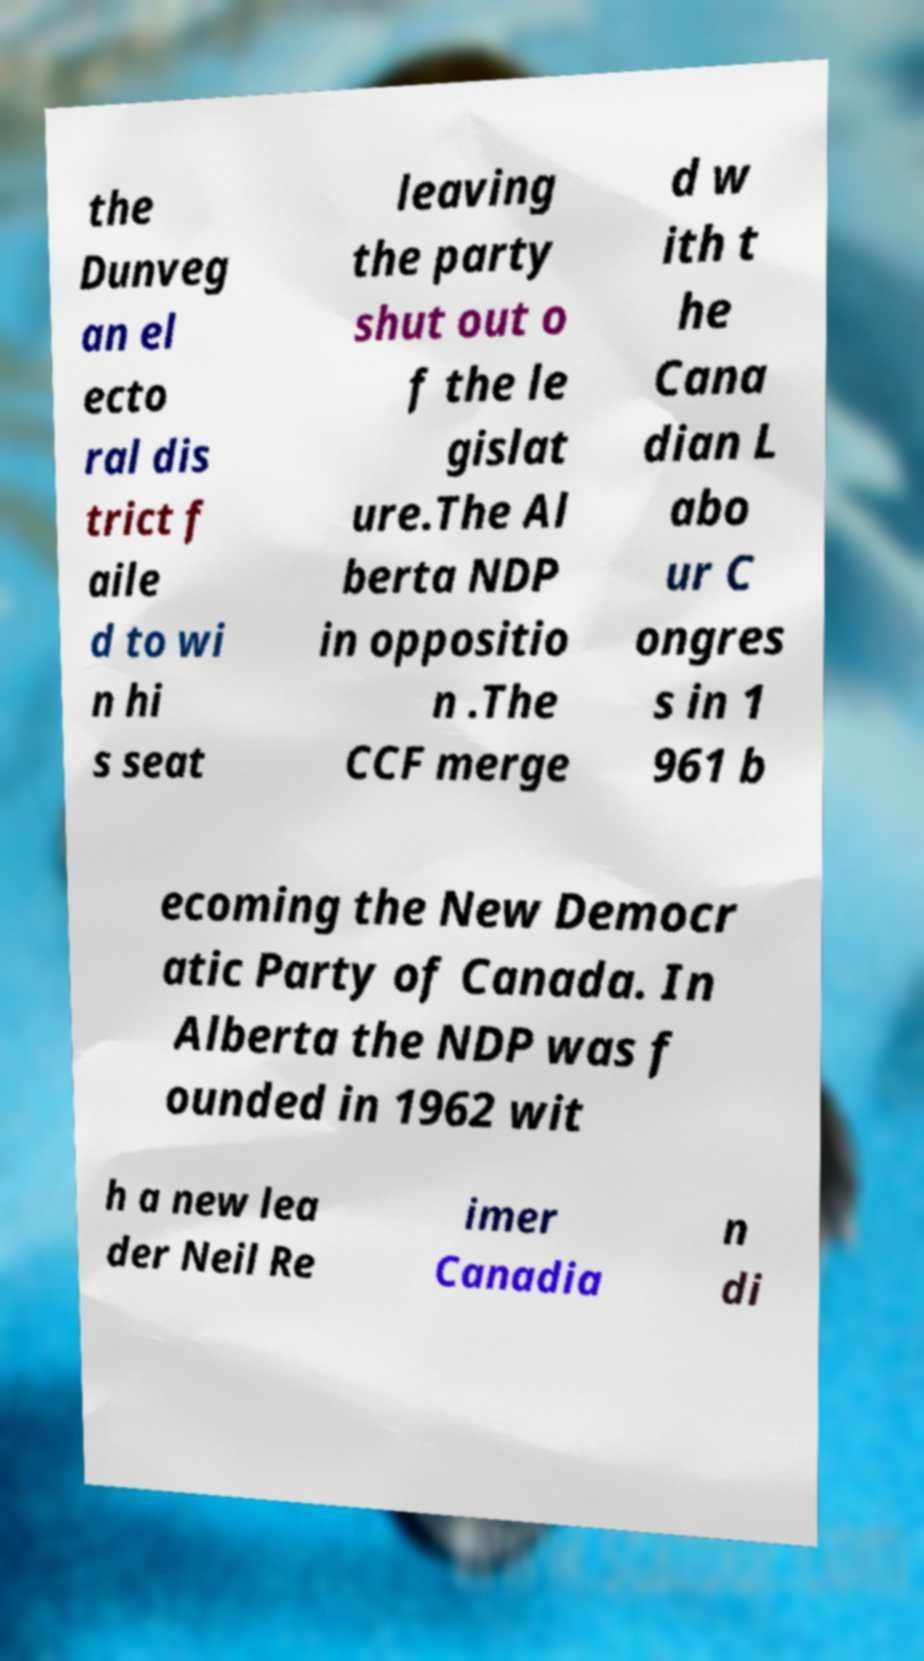For documentation purposes, I need the text within this image transcribed. Could you provide that? the Dunveg an el ecto ral dis trict f aile d to wi n hi s seat leaving the party shut out o f the le gislat ure.The Al berta NDP in oppositio n .The CCF merge d w ith t he Cana dian L abo ur C ongres s in 1 961 b ecoming the New Democr atic Party of Canada. In Alberta the NDP was f ounded in 1962 wit h a new lea der Neil Re imer Canadia n di 